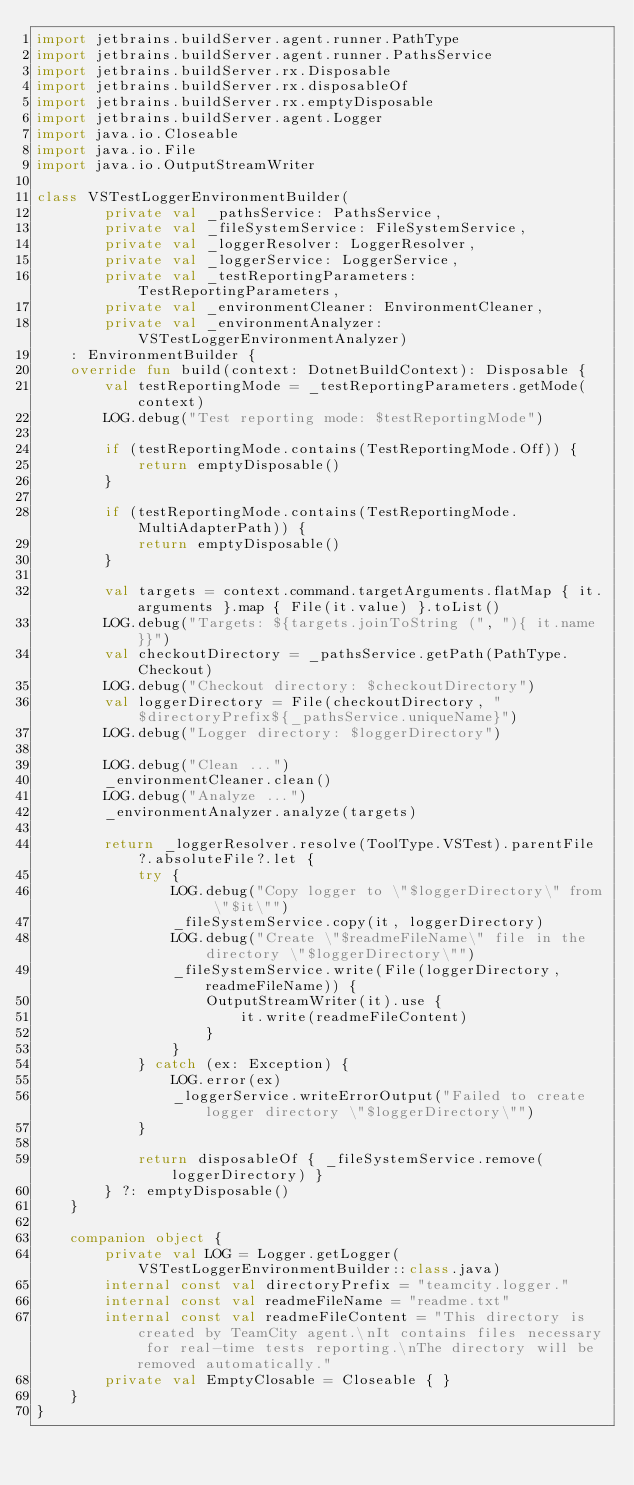<code> <loc_0><loc_0><loc_500><loc_500><_Kotlin_>import jetbrains.buildServer.agent.runner.PathType
import jetbrains.buildServer.agent.runner.PathsService
import jetbrains.buildServer.rx.Disposable
import jetbrains.buildServer.rx.disposableOf
import jetbrains.buildServer.rx.emptyDisposable
import jetbrains.buildServer.agent.Logger
import java.io.Closeable
import java.io.File
import java.io.OutputStreamWriter

class VSTestLoggerEnvironmentBuilder(
        private val _pathsService: PathsService,
        private val _fileSystemService: FileSystemService,
        private val _loggerResolver: LoggerResolver,
        private val _loggerService: LoggerService,
        private val _testReportingParameters: TestReportingParameters,
        private val _environmentCleaner: EnvironmentCleaner,
        private val _environmentAnalyzer: VSTestLoggerEnvironmentAnalyzer)
    : EnvironmentBuilder {
    override fun build(context: DotnetBuildContext): Disposable {
        val testReportingMode = _testReportingParameters.getMode(context)
        LOG.debug("Test reporting mode: $testReportingMode")

        if (testReportingMode.contains(TestReportingMode.Off)) {
            return emptyDisposable()
        }

        if (testReportingMode.contains(TestReportingMode.MultiAdapterPath)) {
            return emptyDisposable()
        }

        val targets = context.command.targetArguments.flatMap { it.arguments }.map { File(it.value) }.toList()
        LOG.debug("Targets: ${targets.joinToString (", "){ it.name }}")
        val checkoutDirectory = _pathsService.getPath(PathType.Checkout)
        LOG.debug("Checkout directory: $checkoutDirectory")
        val loggerDirectory = File(checkoutDirectory, "$directoryPrefix${_pathsService.uniqueName}")
        LOG.debug("Logger directory: $loggerDirectory")

        LOG.debug("Clean ...")
        _environmentCleaner.clean()
        LOG.debug("Analyze ...")
        _environmentAnalyzer.analyze(targets)

        return _loggerResolver.resolve(ToolType.VSTest).parentFile?.absoluteFile?.let {
            try {
                LOG.debug("Copy logger to \"$loggerDirectory\" from \"$it\"")
                _fileSystemService.copy(it, loggerDirectory)
                LOG.debug("Create \"$readmeFileName\" file in the directory \"$loggerDirectory\"")
                _fileSystemService.write(File(loggerDirectory, readmeFileName)) {
                    OutputStreamWriter(it).use {
                        it.write(readmeFileContent)
                    }
                }
            } catch (ex: Exception) {
                LOG.error(ex)
                _loggerService.writeErrorOutput("Failed to create logger directory \"$loggerDirectory\"")
            }

            return disposableOf { _fileSystemService.remove(loggerDirectory) }
        } ?: emptyDisposable()
    }

    companion object {
        private val LOG = Logger.getLogger(VSTestLoggerEnvironmentBuilder::class.java)
        internal const val directoryPrefix = "teamcity.logger."
        internal const val readmeFileName = "readme.txt"
        internal const val readmeFileContent = "This directory is created by TeamCity agent.\nIt contains files necessary for real-time tests reporting.\nThe directory will be removed automatically."
        private val EmptyClosable = Closeable { }
    }
}</code> 